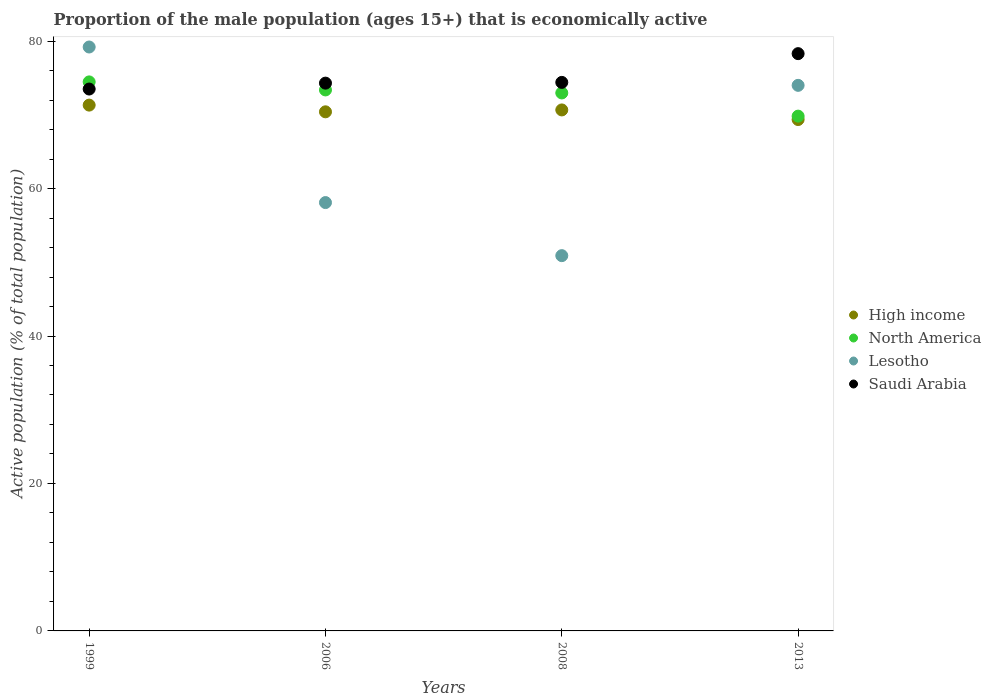What is the proportion of the male population that is economically active in High income in 1999?
Make the answer very short. 71.32. Across all years, what is the maximum proportion of the male population that is economically active in Saudi Arabia?
Ensure brevity in your answer.  78.3. Across all years, what is the minimum proportion of the male population that is economically active in High income?
Provide a succinct answer. 69.36. What is the total proportion of the male population that is economically active in Lesotho in the graph?
Provide a succinct answer. 262.2. What is the difference between the proportion of the male population that is economically active in Saudi Arabia in 2008 and that in 2013?
Your response must be concise. -3.9. What is the difference between the proportion of the male population that is economically active in Lesotho in 2006 and the proportion of the male population that is economically active in High income in 2008?
Ensure brevity in your answer.  -12.57. What is the average proportion of the male population that is economically active in Saudi Arabia per year?
Ensure brevity in your answer.  75.13. In the year 2008, what is the difference between the proportion of the male population that is economically active in Lesotho and proportion of the male population that is economically active in North America?
Ensure brevity in your answer.  -22.07. In how many years, is the proportion of the male population that is economically active in High income greater than 52 %?
Provide a succinct answer. 4. What is the ratio of the proportion of the male population that is economically active in North America in 1999 to that in 2006?
Make the answer very short. 1.01. Is the proportion of the male population that is economically active in Saudi Arabia in 1999 less than that in 2013?
Your answer should be very brief. Yes. Is the difference between the proportion of the male population that is economically active in Lesotho in 2006 and 2013 greater than the difference between the proportion of the male population that is economically active in North America in 2006 and 2013?
Your answer should be compact. No. What is the difference between the highest and the second highest proportion of the male population that is economically active in Lesotho?
Your answer should be very brief. 5.2. What is the difference between the highest and the lowest proportion of the male population that is economically active in North America?
Ensure brevity in your answer.  4.64. In how many years, is the proportion of the male population that is economically active in Saudi Arabia greater than the average proportion of the male population that is economically active in Saudi Arabia taken over all years?
Your response must be concise. 1. Does the proportion of the male population that is economically active in Saudi Arabia monotonically increase over the years?
Your answer should be compact. Yes. Is the proportion of the male population that is economically active in North America strictly greater than the proportion of the male population that is economically active in Saudi Arabia over the years?
Your response must be concise. No. How many dotlines are there?
Offer a very short reply. 4. How many years are there in the graph?
Your answer should be compact. 4. What is the difference between two consecutive major ticks on the Y-axis?
Offer a terse response. 20. Are the values on the major ticks of Y-axis written in scientific E-notation?
Provide a succinct answer. No. Does the graph contain any zero values?
Make the answer very short. No. How are the legend labels stacked?
Your answer should be compact. Vertical. What is the title of the graph?
Make the answer very short. Proportion of the male population (ages 15+) that is economically active. Does "Madagascar" appear as one of the legend labels in the graph?
Provide a succinct answer. No. What is the label or title of the Y-axis?
Give a very brief answer. Active population (% of total population). What is the Active population (% of total population) of High income in 1999?
Offer a terse response. 71.32. What is the Active population (% of total population) in North America in 1999?
Provide a short and direct response. 74.47. What is the Active population (% of total population) in Lesotho in 1999?
Your answer should be compact. 79.2. What is the Active population (% of total population) of Saudi Arabia in 1999?
Offer a terse response. 73.5. What is the Active population (% of total population) of High income in 2006?
Ensure brevity in your answer.  70.41. What is the Active population (% of total population) in North America in 2006?
Provide a succinct answer. 73.38. What is the Active population (% of total population) in Lesotho in 2006?
Your answer should be compact. 58.1. What is the Active population (% of total population) of Saudi Arabia in 2006?
Give a very brief answer. 74.3. What is the Active population (% of total population) in High income in 2008?
Your answer should be compact. 70.67. What is the Active population (% of total population) of North America in 2008?
Your answer should be very brief. 72.97. What is the Active population (% of total population) of Lesotho in 2008?
Keep it short and to the point. 50.9. What is the Active population (% of total population) in Saudi Arabia in 2008?
Provide a succinct answer. 74.4. What is the Active population (% of total population) in High income in 2013?
Your answer should be very brief. 69.36. What is the Active population (% of total population) in North America in 2013?
Provide a succinct answer. 69.82. What is the Active population (% of total population) of Saudi Arabia in 2013?
Offer a terse response. 78.3. Across all years, what is the maximum Active population (% of total population) in High income?
Provide a short and direct response. 71.32. Across all years, what is the maximum Active population (% of total population) of North America?
Provide a succinct answer. 74.47. Across all years, what is the maximum Active population (% of total population) of Lesotho?
Your response must be concise. 79.2. Across all years, what is the maximum Active population (% of total population) in Saudi Arabia?
Give a very brief answer. 78.3. Across all years, what is the minimum Active population (% of total population) of High income?
Offer a very short reply. 69.36. Across all years, what is the minimum Active population (% of total population) in North America?
Your response must be concise. 69.82. Across all years, what is the minimum Active population (% of total population) in Lesotho?
Ensure brevity in your answer.  50.9. Across all years, what is the minimum Active population (% of total population) in Saudi Arabia?
Offer a very short reply. 73.5. What is the total Active population (% of total population) in High income in the graph?
Make the answer very short. 281.76. What is the total Active population (% of total population) in North America in the graph?
Provide a succinct answer. 290.64. What is the total Active population (% of total population) in Lesotho in the graph?
Give a very brief answer. 262.2. What is the total Active population (% of total population) of Saudi Arabia in the graph?
Your response must be concise. 300.5. What is the difference between the Active population (% of total population) in High income in 1999 and that in 2006?
Offer a very short reply. 0.91. What is the difference between the Active population (% of total population) of North America in 1999 and that in 2006?
Your answer should be compact. 1.09. What is the difference between the Active population (% of total population) of Lesotho in 1999 and that in 2006?
Make the answer very short. 21.1. What is the difference between the Active population (% of total population) in Saudi Arabia in 1999 and that in 2006?
Give a very brief answer. -0.8. What is the difference between the Active population (% of total population) in High income in 1999 and that in 2008?
Your response must be concise. 0.65. What is the difference between the Active population (% of total population) in North America in 1999 and that in 2008?
Make the answer very short. 1.5. What is the difference between the Active population (% of total population) in Lesotho in 1999 and that in 2008?
Ensure brevity in your answer.  28.3. What is the difference between the Active population (% of total population) in High income in 1999 and that in 2013?
Keep it short and to the point. 1.96. What is the difference between the Active population (% of total population) of North America in 1999 and that in 2013?
Provide a short and direct response. 4.64. What is the difference between the Active population (% of total population) in Lesotho in 1999 and that in 2013?
Offer a terse response. 5.2. What is the difference between the Active population (% of total population) in Saudi Arabia in 1999 and that in 2013?
Provide a short and direct response. -4.8. What is the difference between the Active population (% of total population) in High income in 2006 and that in 2008?
Provide a succinct answer. -0.26. What is the difference between the Active population (% of total population) of North America in 2006 and that in 2008?
Your response must be concise. 0.41. What is the difference between the Active population (% of total population) of Saudi Arabia in 2006 and that in 2008?
Offer a terse response. -0.1. What is the difference between the Active population (% of total population) of High income in 2006 and that in 2013?
Your answer should be very brief. 1.05. What is the difference between the Active population (% of total population) in North America in 2006 and that in 2013?
Keep it short and to the point. 3.55. What is the difference between the Active population (% of total population) in Lesotho in 2006 and that in 2013?
Ensure brevity in your answer.  -15.9. What is the difference between the Active population (% of total population) in Saudi Arabia in 2006 and that in 2013?
Your answer should be compact. -4. What is the difference between the Active population (% of total population) in High income in 2008 and that in 2013?
Your response must be concise. 1.3. What is the difference between the Active population (% of total population) of North America in 2008 and that in 2013?
Your answer should be compact. 3.15. What is the difference between the Active population (% of total population) in Lesotho in 2008 and that in 2013?
Provide a short and direct response. -23.1. What is the difference between the Active population (% of total population) in Saudi Arabia in 2008 and that in 2013?
Offer a very short reply. -3.9. What is the difference between the Active population (% of total population) in High income in 1999 and the Active population (% of total population) in North America in 2006?
Ensure brevity in your answer.  -2.06. What is the difference between the Active population (% of total population) in High income in 1999 and the Active population (% of total population) in Lesotho in 2006?
Offer a terse response. 13.22. What is the difference between the Active population (% of total population) of High income in 1999 and the Active population (% of total population) of Saudi Arabia in 2006?
Your answer should be very brief. -2.98. What is the difference between the Active population (% of total population) of North America in 1999 and the Active population (% of total population) of Lesotho in 2006?
Your answer should be very brief. 16.37. What is the difference between the Active population (% of total population) in North America in 1999 and the Active population (% of total population) in Saudi Arabia in 2006?
Your answer should be compact. 0.17. What is the difference between the Active population (% of total population) in High income in 1999 and the Active population (% of total population) in North America in 2008?
Give a very brief answer. -1.65. What is the difference between the Active population (% of total population) in High income in 1999 and the Active population (% of total population) in Lesotho in 2008?
Keep it short and to the point. 20.42. What is the difference between the Active population (% of total population) in High income in 1999 and the Active population (% of total population) in Saudi Arabia in 2008?
Ensure brevity in your answer.  -3.08. What is the difference between the Active population (% of total population) in North America in 1999 and the Active population (% of total population) in Lesotho in 2008?
Your response must be concise. 23.57. What is the difference between the Active population (% of total population) of North America in 1999 and the Active population (% of total population) of Saudi Arabia in 2008?
Provide a short and direct response. 0.07. What is the difference between the Active population (% of total population) in High income in 1999 and the Active population (% of total population) in North America in 2013?
Your answer should be compact. 1.49. What is the difference between the Active population (% of total population) in High income in 1999 and the Active population (% of total population) in Lesotho in 2013?
Make the answer very short. -2.68. What is the difference between the Active population (% of total population) in High income in 1999 and the Active population (% of total population) in Saudi Arabia in 2013?
Your answer should be compact. -6.98. What is the difference between the Active population (% of total population) of North America in 1999 and the Active population (% of total population) of Lesotho in 2013?
Offer a very short reply. 0.47. What is the difference between the Active population (% of total population) in North America in 1999 and the Active population (% of total population) in Saudi Arabia in 2013?
Offer a terse response. -3.83. What is the difference between the Active population (% of total population) in High income in 2006 and the Active population (% of total population) in North America in 2008?
Offer a terse response. -2.56. What is the difference between the Active population (% of total population) of High income in 2006 and the Active population (% of total population) of Lesotho in 2008?
Provide a succinct answer. 19.51. What is the difference between the Active population (% of total population) of High income in 2006 and the Active population (% of total population) of Saudi Arabia in 2008?
Offer a terse response. -3.99. What is the difference between the Active population (% of total population) of North America in 2006 and the Active population (% of total population) of Lesotho in 2008?
Provide a succinct answer. 22.48. What is the difference between the Active population (% of total population) of North America in 2006 and the Active population (% of total population) of Saudi Arabia in 2008?
Provide a succinct answer. -1.02. What is the difference between the Active population (% of total population) of Lesotho in 2006 and the Active population (% of total population) of Saudi Arabia in 2008?
Provide a short and direct response. -16.3. What is the difference between the Active population (% of total population) of High income in 2006 and the Active population (% of total population) of North America in 2013?
Ensure brevity in your answer.  0.59. What is the difference between the Active population (% of total population) in High income in 2006 and the Active population (% of total population) in Lesotho in 2013?
Make the answer very short. -3.59. What is the difference between the Active population (% of total population) in High income in 2006 and the Active population (% of total population) in Saudi Arabia in 2013?
Your answer should be compact. -7.89. What is the difference between the Active population (% of total population) of North America in 2006 and the Active population (% of total population) of Lesotho in 2013?
Your answer should be compact. -0.62. What is the difference between the Active population (% of total population) in North America in 2006 and the Active population (% of total population) in Saudi Arabia in 2013?
Provide a succinct answer. -4.92. What is the difference between the Active population (% of total population) of Lesotho in 2006 and the Active population (% of total population) of Saudi Arabia in 2013?
Provide a succinct answer. -20.2. What is the difference between the Active population (% of total population) of High income in 2008 and the Active population (% of total population) of North America in 2013?
Your answer should be very brief. 0.84. What is the difference between the Active population (% of total population) in High income in 2008 and the Active population (% of total population) in Lesotho in 2013?
Your response must be concise. -3.33. What is the difference between the Active population (% of total population) of High income in 2008 and the Active population (% of total population) of Saudi Arabia in 2013?
Offer a terse response. -7.63. What is the difference between the Active population (% of total population) of North America in 2008 and the Active population (% of total population) of Lesotho in 2013?
Your answer should be compact. -1.03. What is the difference between the Active population (% of total population) in North America in 2008 and the Active population (% of total population) in Saudi Arabia in 2013?
Your answer should be very brief. -5.33. What is the difference between the Active population (% of total population) in Lesotho in 2008 and the Active population (% of total population) in Saudi Arabia in 2013?
Give a very brief answer. -27.4. What is the average Active population (% of total population) in High income per year?
Keep it short and to the point. 70.44. What is the average Active population (% of total population) of North America per year?
Ensure brevity in your answer.  72.66. What is the average Active population (% of total population) of Lesotho per year?
Make the answer very short. 65.55. What is the average Active population (% of total population) in Saudi Arabia per year?
Your answer should be very brief. 75.12. In the year 1999, what is the difference between the Active population (% of total population) of High income and Active population (% of total population) of North America?
Your answer should be compact. -3.15. In the year 1999, what is the difference between the Active population (% of total population) of High income and Active population (% of total population) of Lesotho?
Offer a terse response. -7.88. In the year 1999, what is the difference between the Active population (% of total population) of High income and Active population (% of total population) of Saudi Arabia?
Your response must be concise. -2.18. In the year 1999, what is the difference between the Active population (% of total population) of North America and Active population (% of total population) of Lesotho?
Your answer should be compact. -4.73. In the year 1999, what is the difference between the Active population (% of total population) in North America and Active population (% of total population) in Saudi Arabia?
Make the answer very short. 0.97. In the year 1999, what is the difference between the Active population (% of total population) of Lesotho and Active population (% of total population) of Saudi Arabia?
Provide a succinct answer. 5.7. In the year 2006, what is the difference between the Active population (% of total population) of High income and Active population (% of total population) of North America?
Offer a very short reply. -2.97. In the year 2006, what is the difference between the Active population (% of total population) in High income and Active population (% of total population) in Lesotho?
Your answer should be compact. 12.31. In the year 2006, what is the difference between the Active population (% of total population) in High income and Active population (% of total population) in Saudi Arabia?
Provide a succinct answer. -3.89. In the year 2006, what is the difference between the Active population (% of total population) in North America and Active population (% of total population) in Lesotho?
Your response must be concise. 15.28. In the year 2006, what is the difference between the Active population (% of total population) in North America and Active population (% of total population) in Saudi Arabia?
Your response must be concise. -0.92. In the year 2006, what is the difference between the Active population (% of total population) of Lesotho and Active population (% of total population) of Saudi Arabia?
Your response must be concise. -16.2. In the year 2008, what is the difference between the Active population (% of total population) in High income and Active population (% of total population) in North America?
Offer a terse response. -2.3. In the year 2008, what is the difference between the Active population (% of total population) in High income and Active population (% of total population) in Lesotho?
Provide a short and direct response. 19.77. In the year 2008, what is the difference between the Active population (% of total population) in High income and Active population (% of total population) in Saudi Arabia?
Your answer should be compact. -3.73. In the year 2008, what is the difference between the Active population (% of total population) in North America and Active population (% of total population) in Lesotho?
Make the answer very short. 22.07. In the year 2008, what is the difference between the Active population (% of total population) of North America and Active population (% of total population) of Saudi Arabia?
Offer a terse response. -1.43. In the year 2008, what is the difference between the Active population (% of total population) of Lesotho and Active population (% of total population) of Saudi Arabia?
Your answer should be compact. -23.5. In the year 2013, what is the difference between the Active population (% of total population) of High income and Active population (% of total population) of North America?
Provide a short and direct response. -0.46. In the year 2013, what is the difference between the Active population (% of total population) in High income and Active population (% of total population) in Lesotho?
Offer a very short reply. -4.64. In the year 2013, what is the difference between the Active population (% of total population) in High income and Active population (% of total population) in Saudi Arabia?
Offer a terse response. -8.94. In the year 2013, what is the difference between the Active population (% of total population) in North America and Active population (% of total population) in Lesotho?
Provide a succinct answer. -4.18. In the year 2013, what is the difference between the Active population (% of total population) in North America and Active population (% of total population) in Saudi Arabia?
Give a very brief answer. -8.48. In the year 2013, what is the difference between the Active population (% of total population) in Lesotho and Active population (% of total population) in Saudi Arabia?
Keep it short and to the point. -4.3. What is the ratio of the Active population (% of total population) in High income in 1999 to that in 2006?
Offer a terse response. 1.01. What is the ratio of the Active population (% of total population) of North America in 1999 to that in 2006?
Make the answer very short. 1.01. What is the ratio of the Active population (% of total population) of Lesotho in 1999 to that in 2006?
Provide a short and direct response. 1.36. What is the ratio of the Active population (% of total population) of Saudi Arabia in 1999 to that in 2006?
Provide a succinct answer. 0.99. What is the ratio of the Active population (% of total population) in High income in 1999 to that in 2008?
Your answer should be very brief. 1.01. What is the ratio of the Active population (% of total population) of North America in 1999 to that in 2008?
Your answer should be compact. 1.02. What is the ratio of the Active population (% of total population) of Lesotho in 1999 to that in 2008?
Make the answer very short. 1.56. What is the ratio of the Active population (% of total population) in Saudi Arabia in 1999 to that in 2008?
Give a very brief answer. 0.99. What is the ratio of the Active population (% of total population) in High income in 1999 to that in 2013?
Make the answer very short. 1.03. What is the ratio of the Active population (% of total population) in North America in 1999 to that in 2013?
Offer a very short reply. 1.07. What is the ratio of the Active population (% of total population) in Lesotho in 1999 to that in 2013?
Ensure brevity in your answer.  1.07. What is the ratio of the Active population (% of total population) in Saudi Arabia in 1999 to that in 2013?
Keep it short and to the point. 0.94. What is the ratio of the Active population (% of total population) of High income in 2006 to that in 2008?
Provide a short and direct response. 1. What is the ratio of the Active population (% of total population) in North America in 2006 to that in 2008?
Your response must be concise. 1.01. What is the ratio of the Active population (% of total population) in Lesotho in 2006 to that in 2008?
Ensure brevity in your answer.  1.14. What is the ratio of the Active population (% of total population) of High income in 2006 to that in 2013?
Provide a succinct answer. 1.02. What is the ratio of the Active population (% of total population) in North America in 2006 to that in 2013?
Keep it short and to the point. 1.05. What is the ratio of the Active population (% of total population) in Lesotho in 2006 to that in 2013?
Provide a succinct answer. 0.79. What is the ratio of the Active population (% of total population) of Saudi Arabia in 2006 to that in 2013?
Keep it short and to the point. 0.95. What is the ratio of the Active population (% of total population) of High income in 2008 to that in 2013?
Provide a short and direct response. 1.02. What is the ratio of the Active population (% of total population) of North America in 2008 to that in 2013?
Your answer should be very brief. 1.04. What is the ratio of the Active population (% of total population) of Lesotho in 2008 to that in 2013?
Make the answer very short. 0.69. What is the ratio of the Active population (% of total population) in Saudi Arabia in 2008 to that in 2013?
Your answer should be very brief. 0.95. What is the difference between the highest and the second highest Active population (% of total population) of High income?
Make the answer very short. 0.65. What is the difference between the highest and the second highest Active population (% of total population) in North America?
Offer a very short reply. 1.09. What is the difference between the highest and the second highest Active population (% of total population) in Saudi Arabia?
Provide a short and direct response. 3.9. What is the difference between the highest and the lowest Active population (% of total population) in High income?
Your answer should be very brief. 1.96. What is the difference between the highest and the lowest Active population (% of total population) of North America?
Offer a terse response. 4.64. What is the difference between the highest and the lowest Active population (% of total population) in Lesotho?
Make the answer very short. 28.3. 